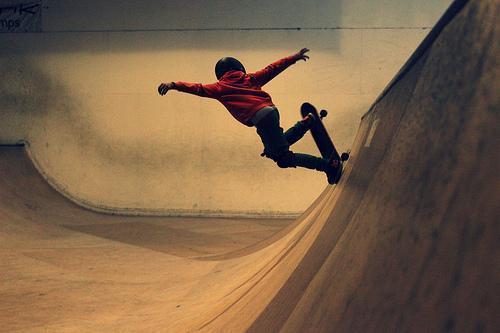How many people in the photo?
Give a very brief answer. 1. 